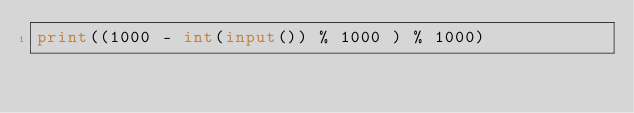<code> <loc_0><loc_0><loc_500><loc_500><_Python_>print((1000 - int(input()) % 1000 ) % 1000)</code> 